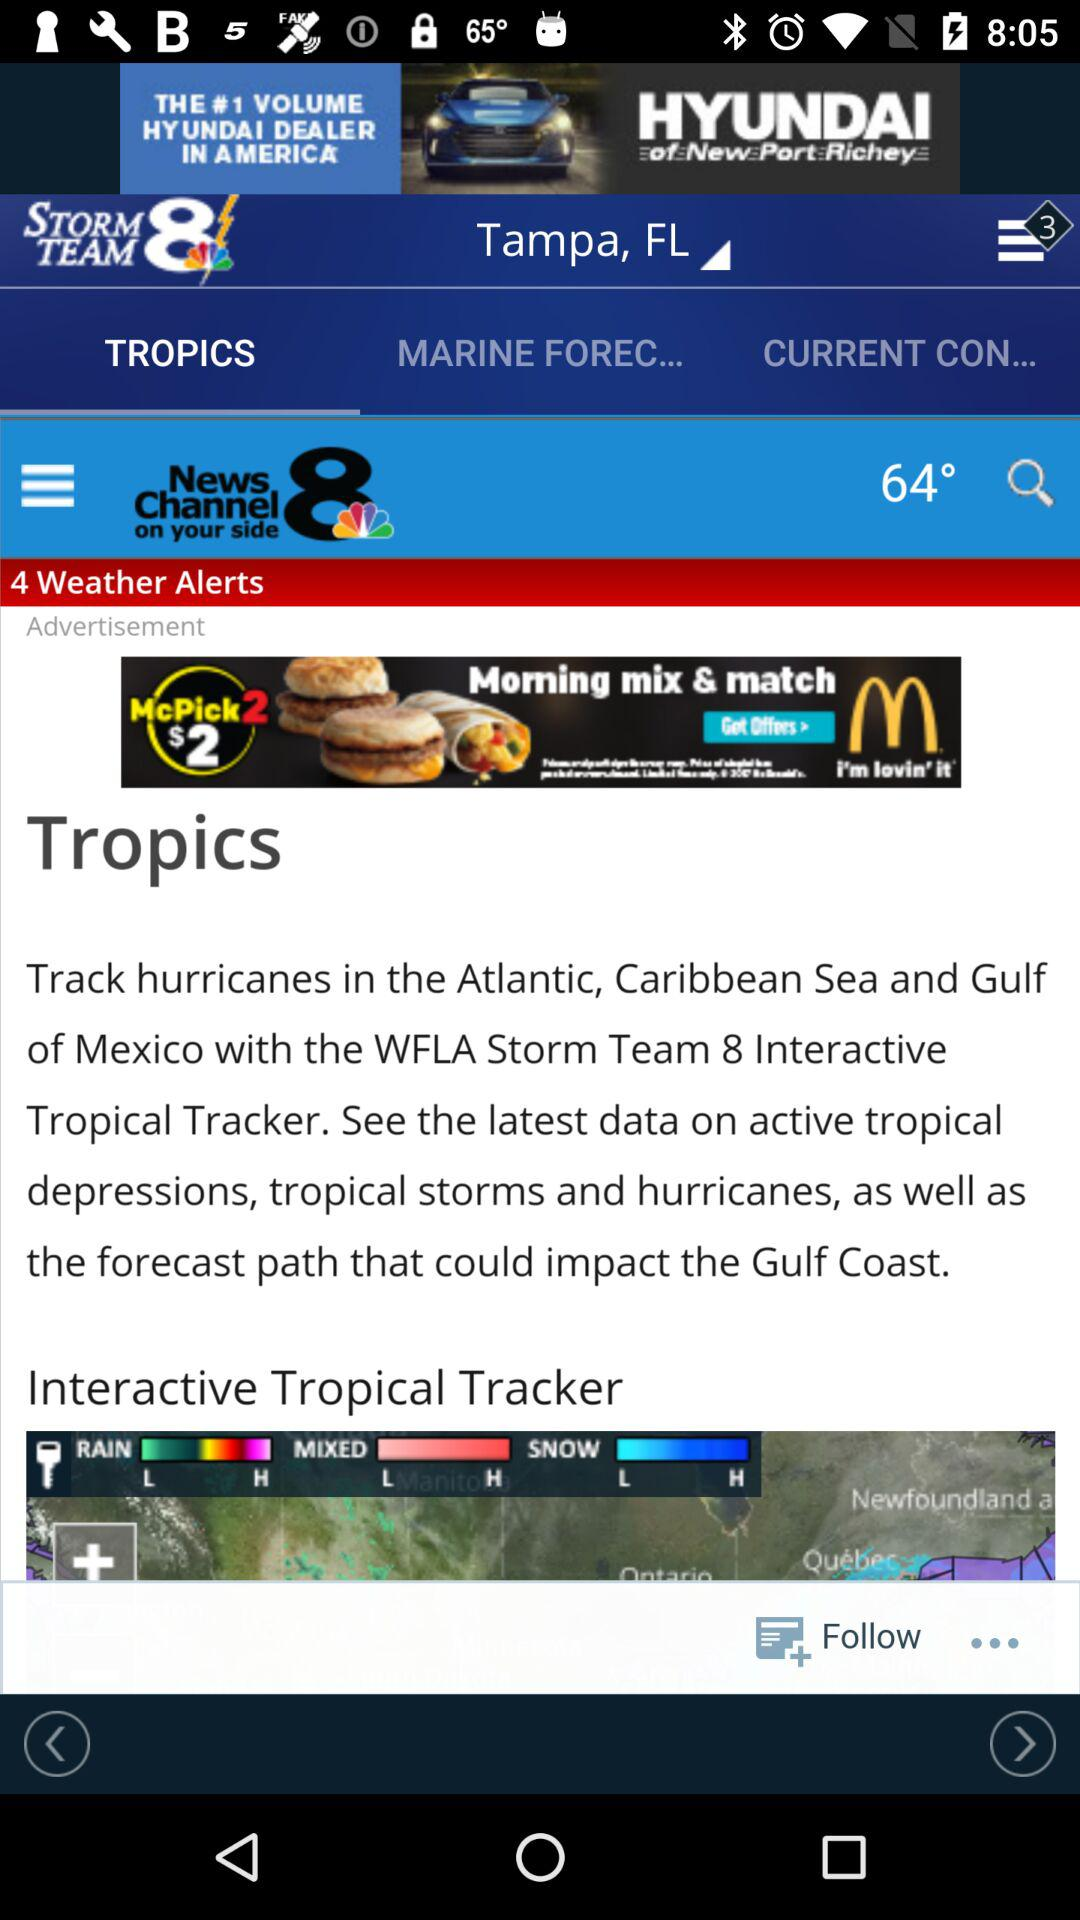How many weather alerts are there? There are 4 weather alerts. 